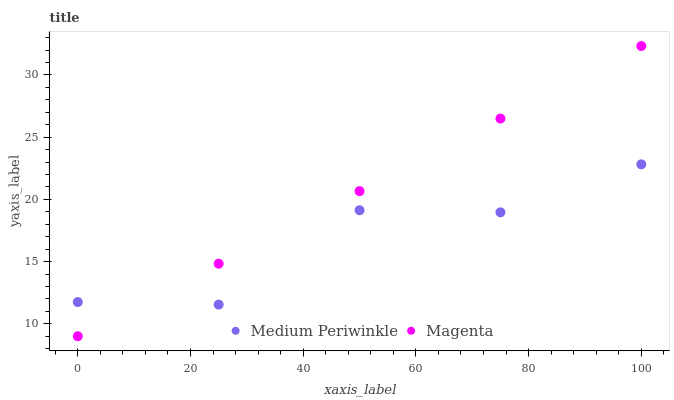Does Medium Periwinkle have the minimum area under the curve?
Answer yes or no. Yes. Does Magenta have the maximum area under the curve?
Answer yes or no. Yes. Does Medium Periwinkle have the maximum area under the curve?
Answer yes or no. No. Is Magenta the smoothest?
Answer yes or no. Yes. Is Medium Periwinkle the roughest?
Answer yes or no. Yes. Is Medium Periwinkle the smoothest?
Answer yes or no. No. Does Magenta have the lowest value?
Answer yes or no. Yes. Does Medium Periwinkle have the lowest value?
Answer yes or no. No. Does Magenta have the highest value?
Answer yes or no. Yes. Does Medium Periwinkle have the highest value?
Answer yes or no. No. Does Medium Periwinkle intersect Magenta?
Answer yes or no. Yes. Is Medium Periwinkle less than Magenta?
Answer yes or no. No. Is Medium Periwinkle greater than Magenta?
Answer yes or no. No. 